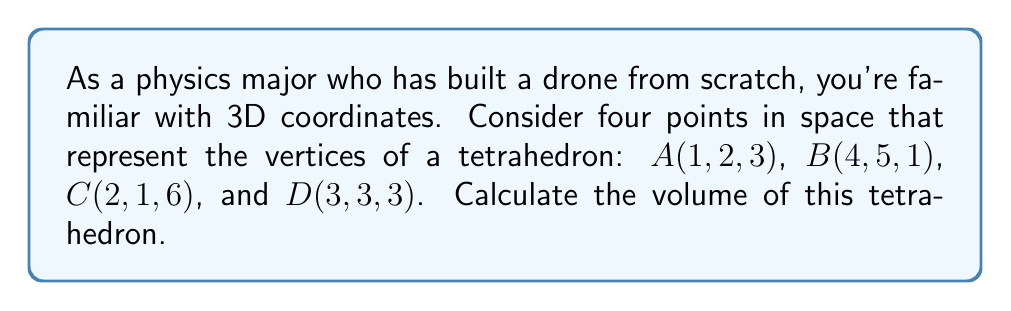Show me your answer to this math problem. To find the volume of a tetrahedron given four non-coplanar points, we can use the following steps:

1) First, we need to calculate three vectors that form the edges of the tetrahedron. Let's choose point A as our reference and create vectors AB, AC, and AD:

   $\vec{AB} = B - A = (4-1, 5-2, 1-3) = (3, 3, -2)$
   $\vec{AC} = C - A = (2-1, 1-2, 6-3) = (1, -1, 3)$
   $\vec{AD} = D - A = (3-1, 3-2, 3-3) = (2, 1, 0)$

2) The volume of a tetrahedron is given by the formula:

   $V = \frac{1}{6}|\det(\vec{AB}, \vec{AC}, \vec{AD})|$

   Where $\det$ is the determinant of the matrix formed by these vectors.

3) Let's form the matrix:

   $$\begin{vmatrix} 
   3 & 1 & 2 \\
   3 & -1 & 1 \\
   -2 & 3 & 0
   \end{vmatrix}$$

4) Calculate the determinant:

   $\det = 3((-1)(0) - (1)(3)) - 1((3)(0) - (-2)(1)) + 2((3)(3) - (-2)(-1))$
   $= 3(-3) - 1(2) + 2(9+2)$
   $= -9 - 2 + 22$
   $= 11$

5) Now, we can calculate the volume:

   $V = \frac{1}{6}|11| = \frac{11}{6}$

Therefore, the volume of the tetrahedron is $\frac{11}{6}$ cubic units.
Answer: $\frac{11}{6}$ cubic units 